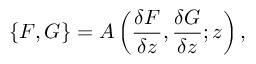<formula> <loc_0><loc_0><loc_500><loc_500>\{ F , G \} = A \left ( \frac { \delta F } { \delta z } , \frac { \delta G } { \delta z } ; z \right ) ,</formula> 